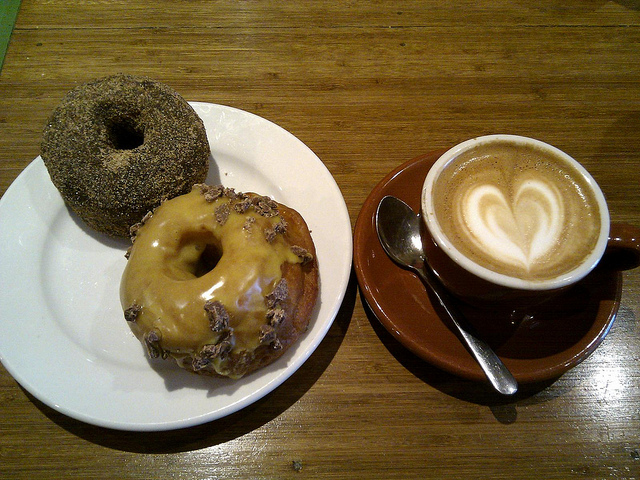What can you see in the image? The image vividly displays a pleasing breakfast scene featuring two appetizing doughnuts on a clean white plate, accompanied by a perfectly made cup of cappuccino. The cappuccino boasts a delicate latte art resembling a heart, exuding warmth and craft. Additionally, a silver spoon rests gracefully on the cappuccino's saucer, completing the setup poised on a wooden table suggesting an indoor café ambiance. 